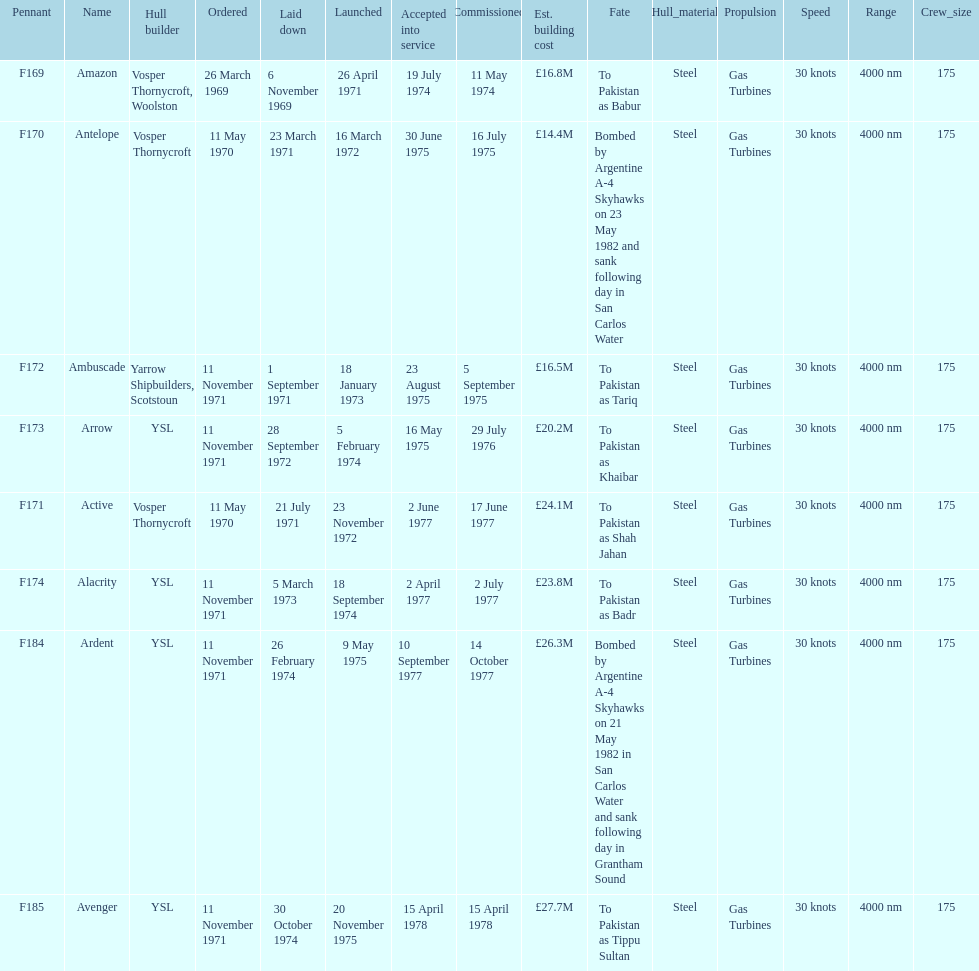What is the last recorded pennant? F185. 